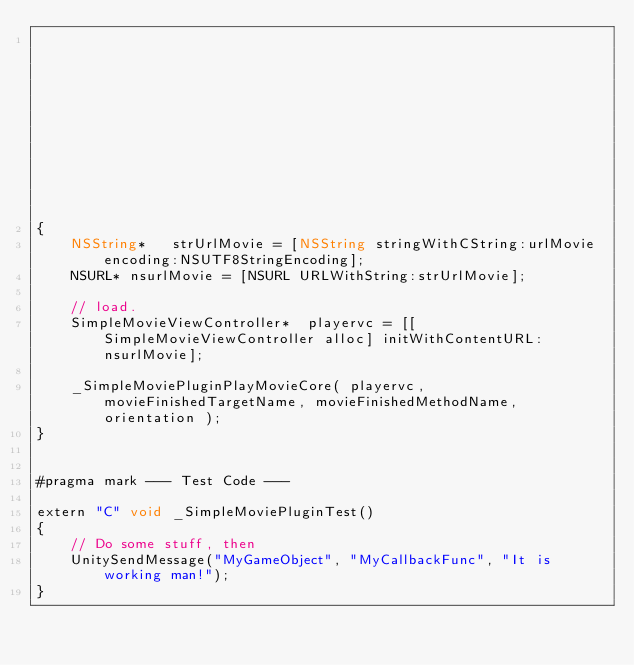Convert code to text. <code><loc_0><loc_0><loc_500><loc_500><_ObjectiveC_>																							 const int orientation = 0 )
{
	NSString*	strUrlMovie	= [NSString stringWithCString:urlMovie encoding:NSUTF8StringEncoding];
	NSURL* nsurlMovie = [NSURL URLWithString:strUrlMovie];
	
	// load.
	SimpleMovieViewController*	playervc = [[SimpleMovieViewController alloc] initWithContentURL:nsurlMovie];
	
	_SimpleMoviePluginPlayMovieCore( playervc, movieFinishedTargetName, movieFinishedMethodName, orientation );
}


#pragma mark --- Test Code ---

extern "C" void _SimpleMoviePluginTest()
{
	// Do some stuff, then
	UnitySendMessage("MyGameObject", "MyCallbackFunc", "It is working man!");
}


</code> 